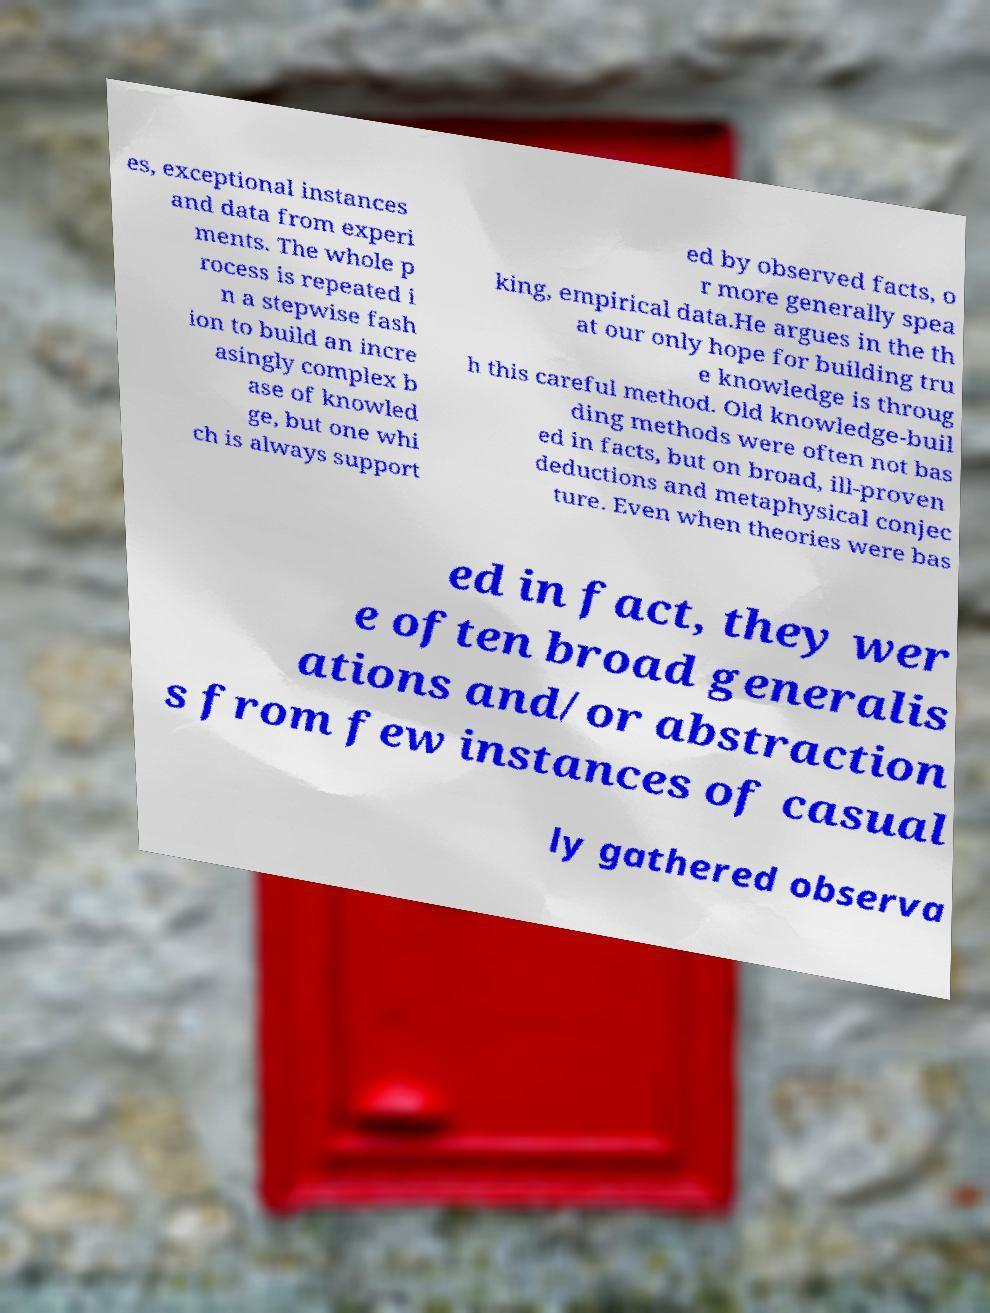What messages or text are displayed in this image? I need them in a readable, typed format. es, exceptional instances and data from experi ments. The whole p rocess is repeated i n a stepwise fash ion to build an incre asingly complex b ase of knowled ge, but one whi ch is always support ed by observed facts, o r more generally spea king, empirical data.He argues in the th at our only hope for building tru e knowledge is throug h this careful method. Old knowledge-buil ding methods were often not bas ed in facts, but on broad, ill-proven deductions and metaphysical conjec ture. Even when theories were bas ed in fact, they wer e often broad generalis ations and/or abstraction s from few instances of casual ly gathered observa 